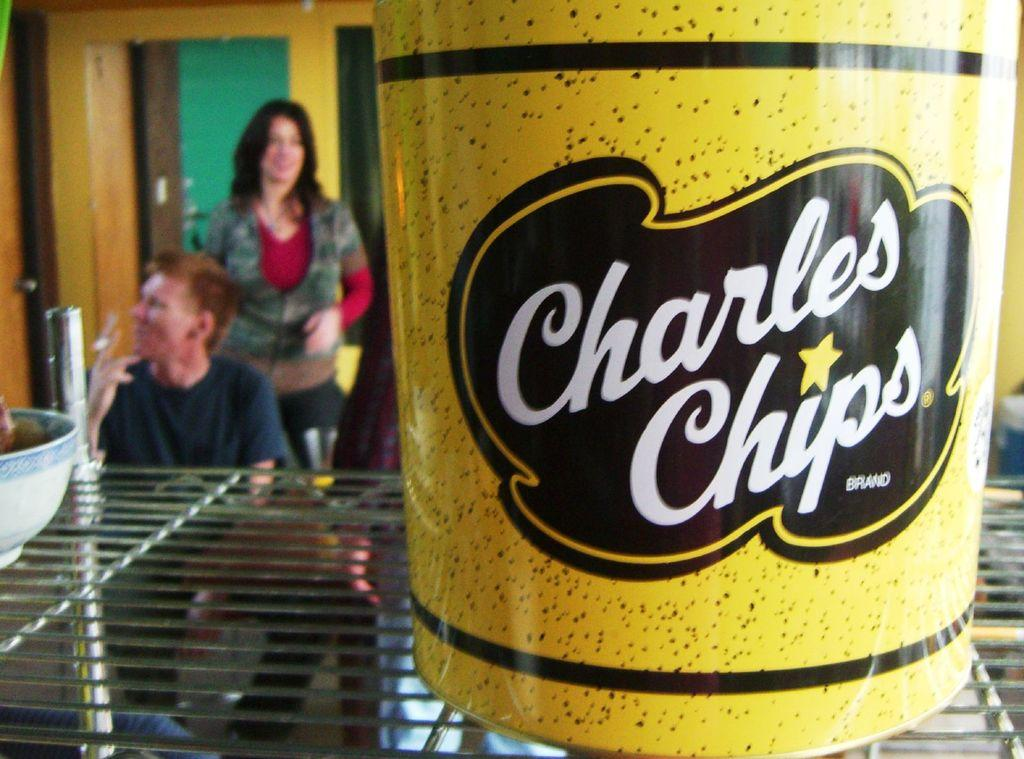What color is the object on the grill in the image? The object on the grill is yellow. What can be seen on the left side of the image? There is a bowl on the left side of the image. What is visible in the background of the image? There are people, a wall, a door, and a floor visible in the background. What type of gold drink can be seen in the book in the image? There is no gold drink or book present in the image. What type of book is the person reading in the image? There is no book or person reading in the image. 